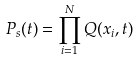Convert formula to latex. <formula><loc_0><loc_0><loc_500><loc_500>P _ { s } ( t ) = \prod _ { i = 1 } ^ { N } Q ( x _ { i } , t )</formula> 